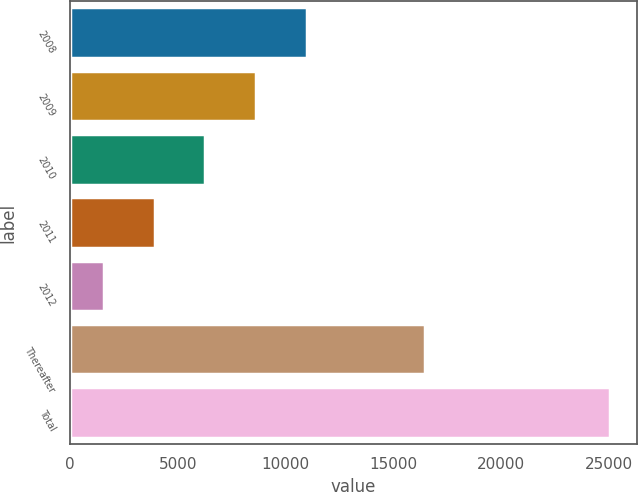Convert chart to OTSL. <chart><loc_0><loc_0><loc_500><loc_500><bar_chart><fcel>2008<fcel>2009<fcel>2010<fcel>2011<fcel>2012<fcel>Thereafter<fcel>Total<nl><fcel>10981.4<fcel>8633.8<fcel>6286.2<fcel>3938.6<fcel>1591<fcel>16485<fcel>25067<nl></chart> 